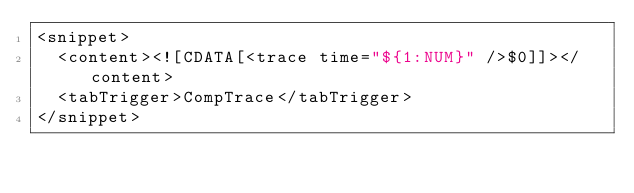Convert code to text. <code><loc_0><loc_0><loc_500><loc_500><_XML_><snippet>
	<content><![CDATA[<trace time="${1:NUM}" />$0]]></content>
	<tabTrigger>CompTrace</tabTrigger>
</snippet></code> 